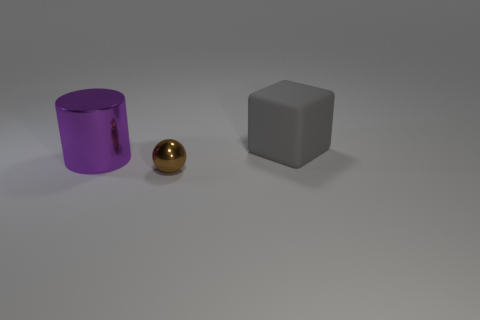Add 3 small brown objects. How many objects exist? 6 Subtract all cubes. How many objects are left? 2 Subtract 0 blue cylinders. How many objects are left? 3 Subtract all small brown balls. Subtract all purple cylinders. How many objects are left? 1 Add 3 small shiny balls. How many small shiny balls are left? 4 Add 1 gray matte blocks. How many gray matte blocks exist? 2 